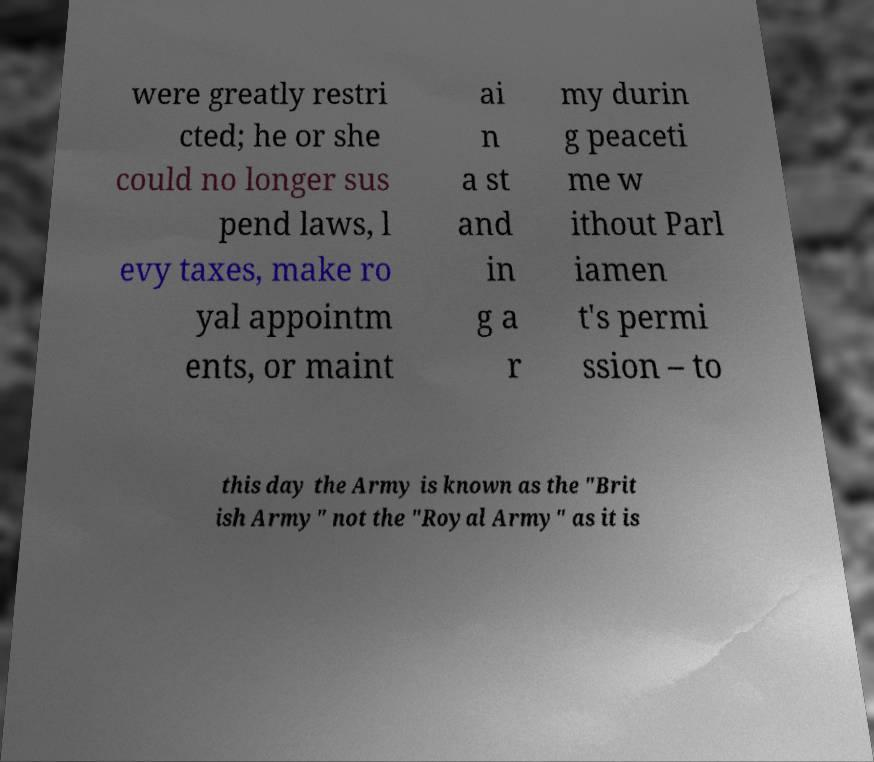For documentation purposes, I need the text within this image transcribed. Could you provide that? were greatly restri cted; he or she could no longer sus pend laws, l evy taxes, make ro yal appointm ents, or maint ai n a st and in g a r my durin g peaceti me w ithout Parl iamen t's permi ssion – to this day the Army is known as the "Brit ish Army" not the "Royal Army" as it is 